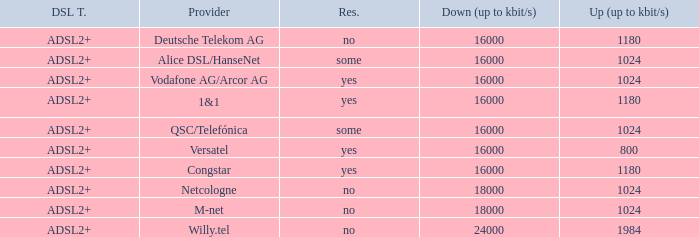Can you parse all the data within this table? {'header': ['DSL T.', 'Provider', 'Res.', 'Down (up to kbit/s)', 'Up (up to kbit/s)'], 'rows': [['ADSL2+', 'Deutsche Telekom AG', 'no', '16000', '1180'], ['ADSL2+', 'Alice DSL/HanseNet', 'some', '16000', '1024'], ['ADSL2+', 'Vodafone AG/Arcor AG', 'yes', '16000', '1024'], ['ADSL2+', '1&1', 'yes', '16000', '1180'], ['ADSL2+', 'QSC/Telefónica', 'some', '16000', '1024'], ['ADSL2+', 'Versatel', 'yes', '16000', '800'], ['ADSL2+', 'Congstar', 'yes', '16000', '1180'], ['ADSL2+', 'Netcologne', 'no', '18000', '1024'], ['ADSL2+', 'M-net', 'no', '18000', '1024'], ['ADSL2+', 'Willy.tel', 'no', '24000', '1984']]} Who are all of the telecom providers for which the upload rate is 1024 kbits and the resale category is yes? Vodafone AG/Arcor AG. 